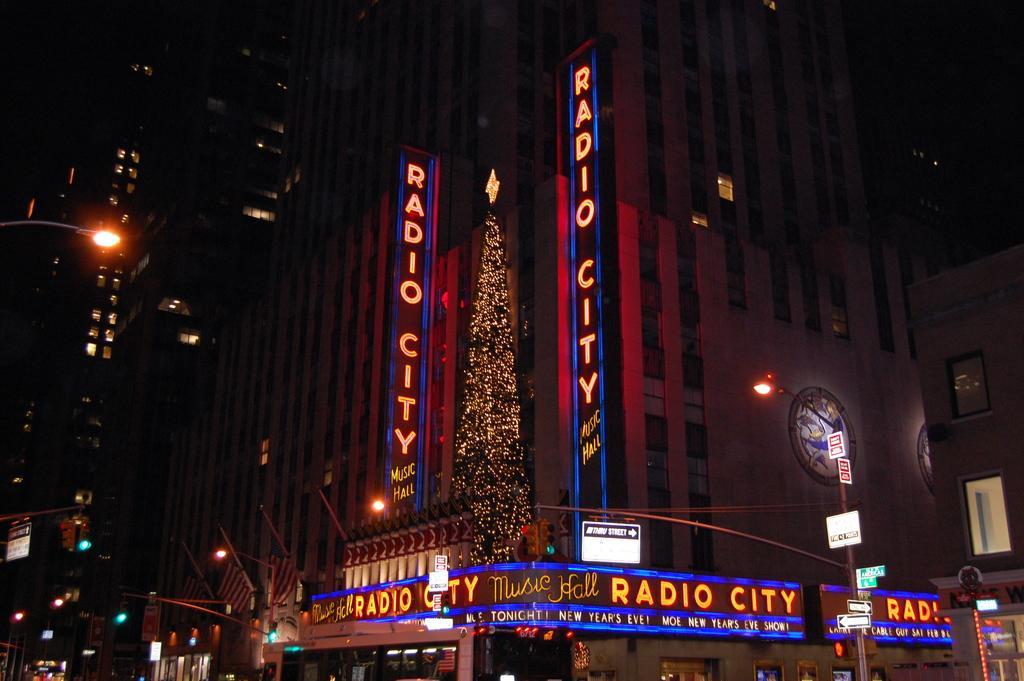Can you describe this image briefly? This is the picture of a place where we have some buildings to which there are some words which has some lights and around there are some poles which has some lights and boards. 